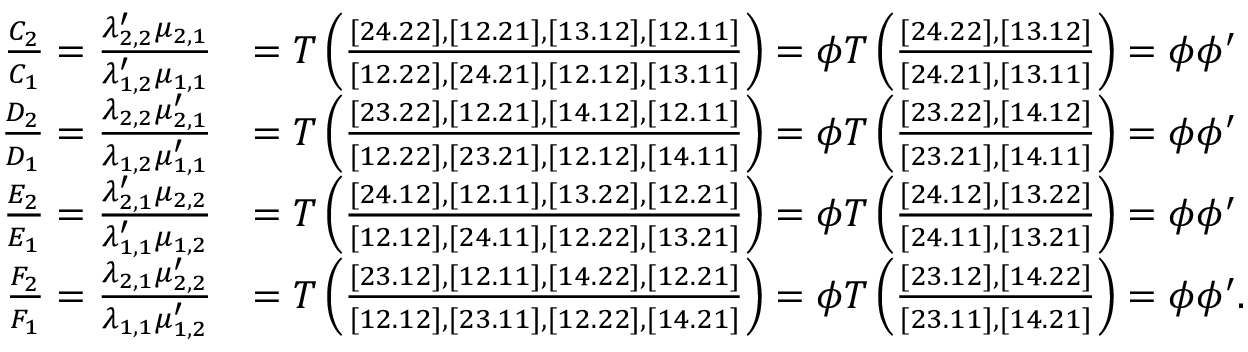Convert formula to latex. <formula><loc_0><loc_0><loc_500><loc_500>\begin{array} { r l } { \frac { C _ { 2 } } { C _ { 1 } } = \frac { \lambda _ { 2 , 2 } ^ { \prime } \mu _ { 2 , 1 } } { \lambda _ { 1 , 2 } ^ { \prime } \mu _ { 1 , 1 } } } & { = T \left ( \frac { [ 2 4 . 2 2 ] , [ 1 2 . 2 1 ] , [ 1 3 . 1 2 ] , [ 1 2 . 1 1 ] } { [ 1 2 . 2 2 ] , [ 2 4 . 2 1 ] , [ 1 2 . 1 2 ] , [ 1 3 . 1 1 ] } \right ) = \phi T \left ( \frac { [ 2 4 . 2 2 ] , [ 1 3 . 1 2 ] } { [ 2 4 . 2 1 ] , [ 1 3 . 1 1 ] } \right ) = \phi \phi ^ { \prime } } \\ { \frac { D _ { 2 } } { D _ { 1 } } = \frac { \lambda _ { 2 , 2 } \mu _ { 2 , 1 } ^ { \prime } } { \lambda _ { 1 , 2 } \mu _ { 1 , 1 } ^ { \prime } } } & { = T \left ( \frac { [ 2 3 . 2 2 ] , [ 1 2 . 2 1 ] , [ 1 4 . 1 2 ] , [ 1 2 . 1 1 ] } { [ 1 2 . 2 2 ] , [ 2 3 . 2 1 ] , [ 1 2 . 1 2 ] , [ 1 4 . 1 1 ] } \right ) = \phi T \left ( \frac { [ 2 3 . 2 2 ] , [ 1 4 . 1 2 ] } { [ 2 3 . 2 1 ] , [ 1 4 . 1 1 ] } \right ) = \phi \phi ^ { \prime } } \\ { \frac { E _ { 2 } } { E _ { 1 } } = \frac { \lambda _ { 2 , 1 } ^ { \prime } \mu _ { 2 , 2 } } { \lambda _ { 1 , 1 } ^ { \prime } \mu _ { 1 , 2 } } } & { = T \left ( \frac { [ 2 4 . 1 2 ] , [ 1 2 . 1 1 ] , [ 1 3 . 2 2 ] , [ 1 2 . 2 1 ] } { [ 1 2 . 1 2 ] , [ 2 4 . 1 1 ] , [ 1 2 . 2 2 ] , [ 1 3 . 2 1 ] } \right ) = \phi T \left ( \frac { [ 2 4 . 1 2 ] , [ 1 3 . 2 2 ] } { [ 2 4 . 1 1 ] , [ 1 3 . 2 1 ] } \right ) = \phi \phi ^ { \prime } } \\ { \frac { F _ { 2 } } { F _ { 1 } } = \frac { \lambda _ { 2 , 1 } \mu _ { 2 , 2 } ^ { \prime } } { \lambda _ { 1 , 1 } \mu _ { 1 , 2 } ^ { \prime } } } & { = T \left ( \frac { [ 2 3 . 1 2 ] , [ 1 2 . 1 1 ] , [ 1 4 . 2 2 ] , [ 1 2 . 2 1 ] } { [ 1 2 . 1 2 ] , [ 2 3 . 1 1 ] , [ 1 2 . 2 2 ] , [ 1 4 . 2 1 ] } \right ) = \phi T \left ( \frac { [ 2 3 . 1 2 ] , [ 1 4 . 2 2 ] } { [ 2 3 . 1 1 ] , [ 1 4 . 2 1 ] } \right ) = \phi \phi ^ { \prime } . } \end{array}</formula> 